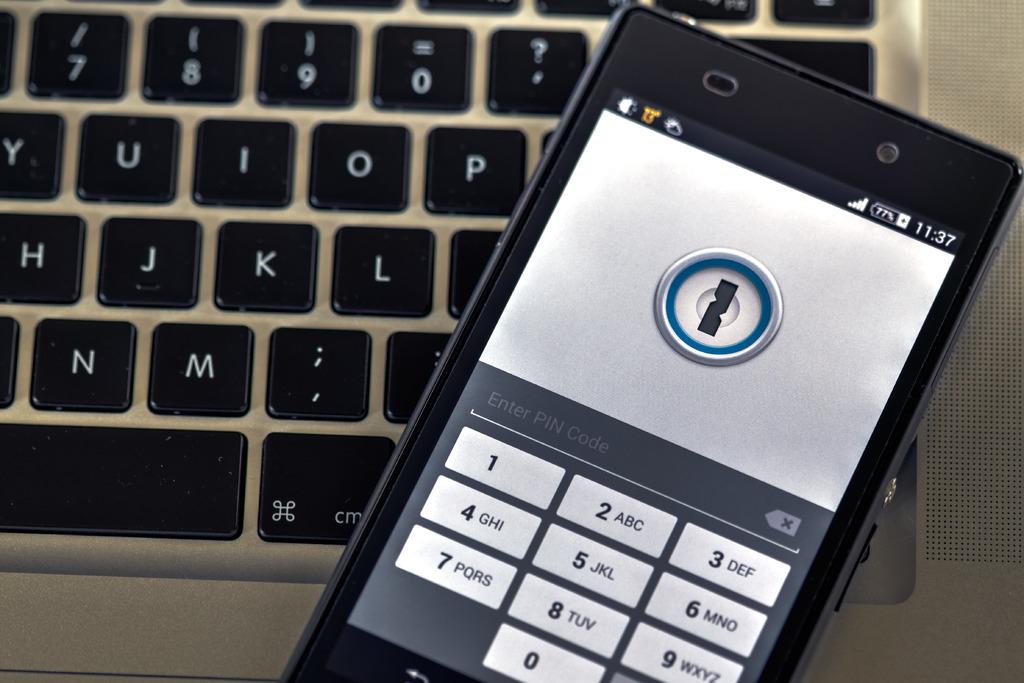What time is displayed on the phone?
Your response must be concise. 11:37. What type of code does the phone say to enter?
Ensure brevity in your answer.  Pin. 